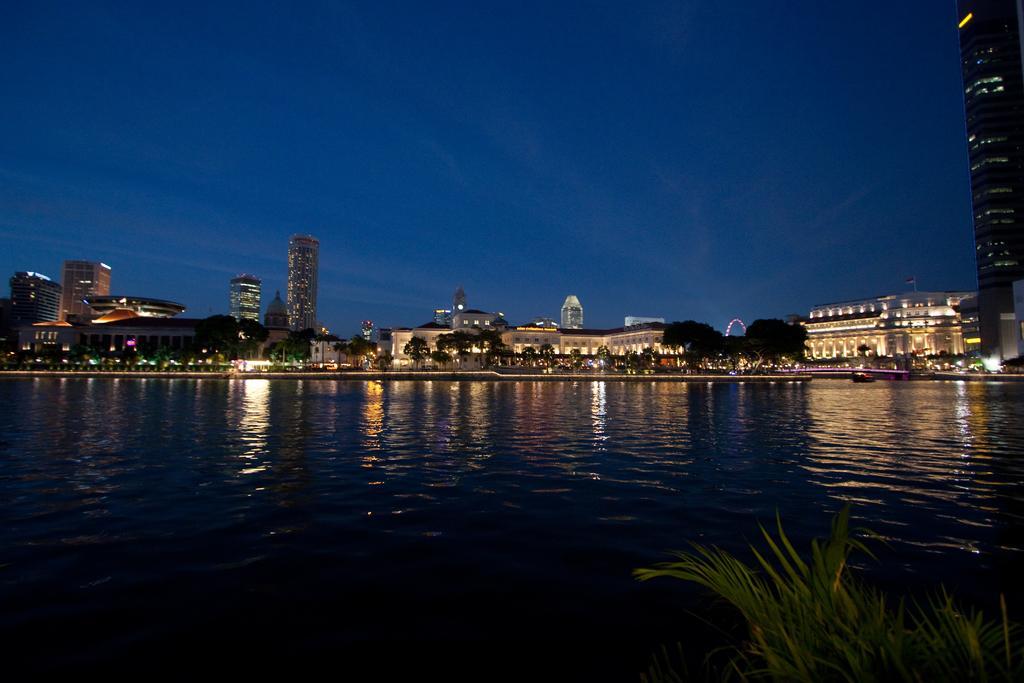In one or two sentences, can you explain what this image depicts? In this image I can see few buildings,trees,lights and the water. The sky is in blue color. 